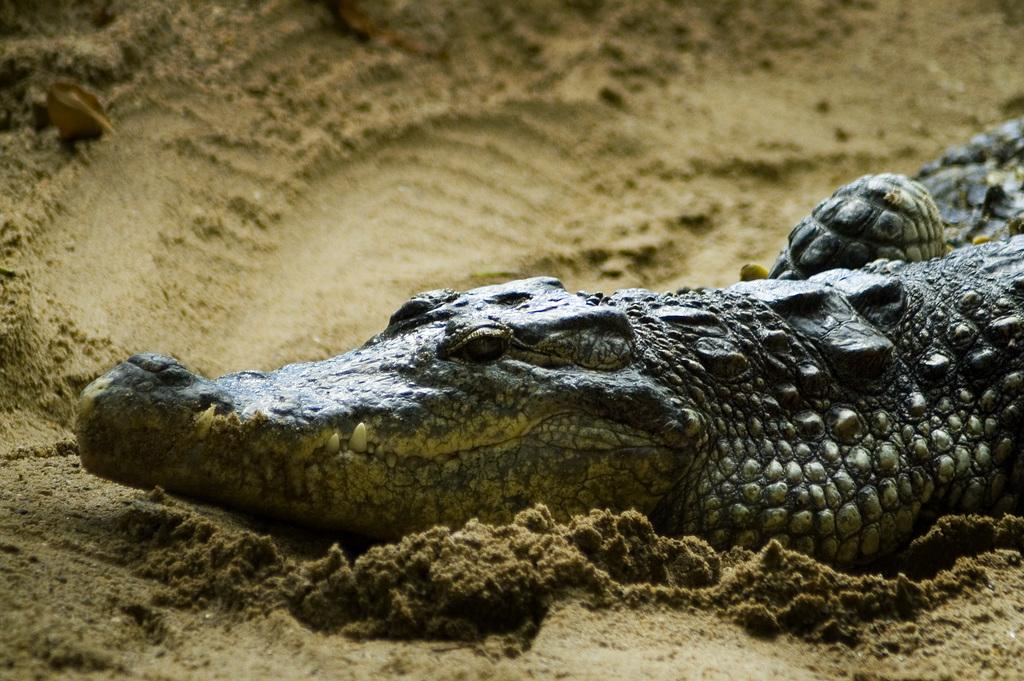What type of animals are present in the image? There are crocodiles in the image. What type of terrain can be seen in the image? There is sand in the image. What type of stamp can be seen on the crocodiles in the image? There are no stamps present on the crocodiles in the image. What type of bushes can be seen in the image? There are no bushes present in the image; it only features crocodiles and sand. 